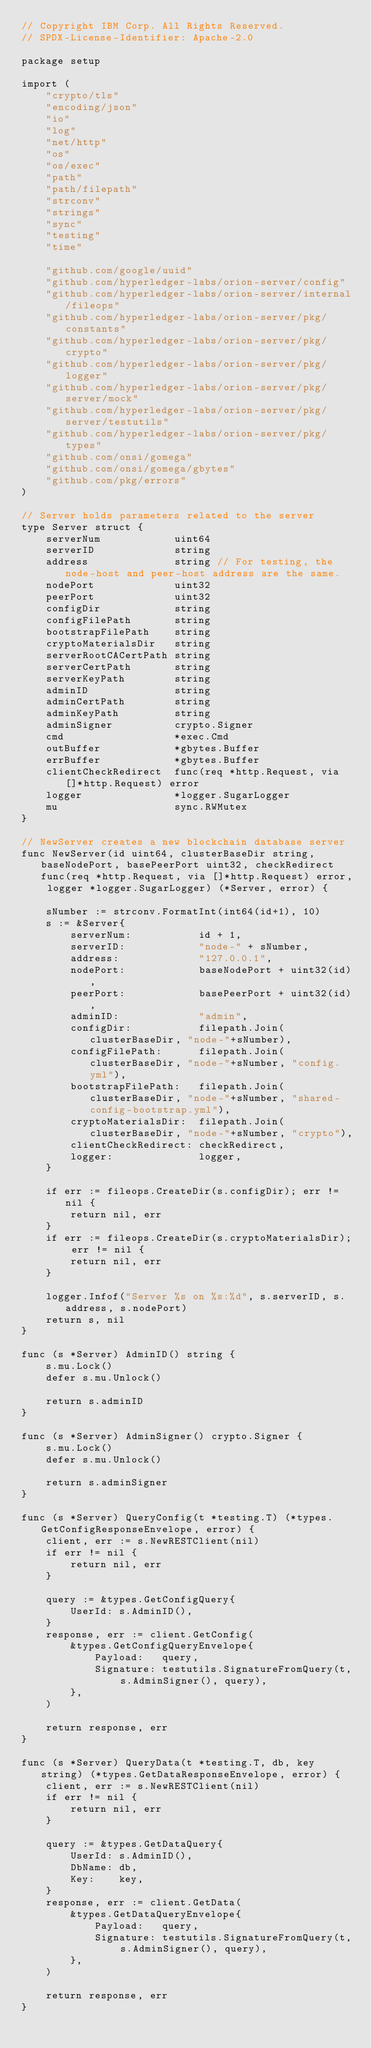<code> <loc_0><loc_0><loc_500><loc_500><_Go_>// Copyright IBM Corp. All Rights Reserved.
// SPDX-License-Identifier: Apache-2.0

package setup

import (
	"crypto/tls"
	"encoding/json"
	"io"
	"log"
	"net/http"
	"os"
	"os/exec"
	"path"
	"path/filepath"
	"strconv"
	"strings"
	"sync"
	"testing"
	"time"

	"github.com/google/uuid"
	"github.com/hyperledger-labs/orion-server/config"
	"github.com/hyperledger-labs/orion-server/internal/fileops"
	"github.com/hyperledger-labs/orion-server/pkg/constants"
	"github.com/hyperledger-labs/orion-server/pkg/crypto"
	"github.com/hyperledger-labs/orion-server/pkg/logger"
	"github.com/hyperledger-labs/orion-server/pkg/server/mock"
	"github.com/hyperledger-labs/orion-server/pkg/server/testutils"
	"github.com/hyperledger-labs/orion-server/pkg/types"
	"github.com/onsi/gomega"
	"github.com/onsi/gomega/gbytes"
	"github.com/pkg/errors"
)

// Server holds parameters related to the server
type Server struct {
	serverNum            uint64
	serverID             string
	address              string // For testing, the node-host and peer-host address are the same.
	nodePort             uint32
	peerPort             uint32
	configDir            string
	configFilePath       string
	bootstrapFilePath    string
	cryptoMaterialsDir   string
	serverRootCACertPath string
	serverCertPath       string
	serverKeyPath        string
	adminID              string
	adminCertPath        string
	adminKeyPath         string
	adminSigner          crypto.Signer
	cmd                  *exec.Cmd
	outBuffer            *gbytes.Buffer
	errBuffer            *gbytes.Buffer
	clientCheckRedirect  func(req *http.Request, via []*http.Request) error
	logger               *logger.SugarLogger
	mu                   sync.RWMutex
}

// NewServer creates a new blockchain database server
func NewServer(id uint64, clusterBaseDir string, baseNodePort, basePeerPort uint32, checkRedirect func(req *http.Request, via []*http.Request) error, logger *logger.SugarLogger) (*Server, error) {

	sNumber := strconv.FormatInt(int64(id+1), 10)
	s := &Server{
		serverNum:           id + 1,
		serverID:            "node-" + sNumber,
		address:             "127.0.0.1",
		nodePort:            baseNodePort + uint32(id),
		peerPort:            basePeerPort + uint32(id),
		adminID:             "admin",
		configDir:           filepath.Join(clusterBaseDir, "node-"+sNumber),
		configFilePath:      filepath.Join(clusterBaseDir, "node-"+sNumber, "config.yml"),
		bootstrapFilePath:   filepath.Join(clusterBaseDir, "node-"+sNumber, "shared-config-bootstrap.yml"),
		cryptoMaterialsDir:  filepath.Join(clusterBaseDir, "node-"+sNumber, "crypto"),
		clientCheckRedirect: checkRedirect,
		logger:              logger,
	}

	if err := fileops.CreateDir(s.configDir); err != nil {
		return nil, err
	}
	if err := fileops.CreateDir(s.cryptoMaterialsDir); err != nil {
		return nil, err
	}

	logger.Infof("Server %s on %s:%d", s.serverID, s.address, s.nodePort)
	return s, nil
}

func (s *Server) AdminID() string {
	s.mu.Lock()
	defer s.mu.Unlock()

	return s.adminID
}

func (s *Server) AdminSigner() crypto.Signer {
	s.mu.Lock()
	defer s.mu.Unlock()

	return s.adminSigner
}

func (s *Server) QueryConfig(t *testing.T) (*types.GetConfigResponseEnvelope, error) {
	client, err := s.NewRESTClient(nil)
	if err != nil {
		return nil, err
	}

	query := &types.GetConfigQuery{
		UserId: s.AdminID(),
	}
	response, err := client.GetConfig(
		&types.GetConfigQueryEnvelope{
			Payload:   query,
			Signature: testutils.SignatureFromQuery(t, s.AdminSigner(), query),
		},
	)

	return response, err
}

func (s *Server) QueryData(t *testing.T, db, key string) (*types.GetDataResponseEnvelope, error) {
	client, err := s.NewRESTClient(nil)
	if err != nil {
		return nil, err
	}

	query := &types.GetDataQuery{
		UserId: s.AdminID(),
		DbName: db,
		Key:    key,
	}
	response, err := client.GetData(
		&types.GetDataQueryEnvelope{
			Payload:   query,
			Signature: testutils.SignatureFromQuery(t, s.AdminSigner(), query),
		},
	)

	return response, err
}
</code> 